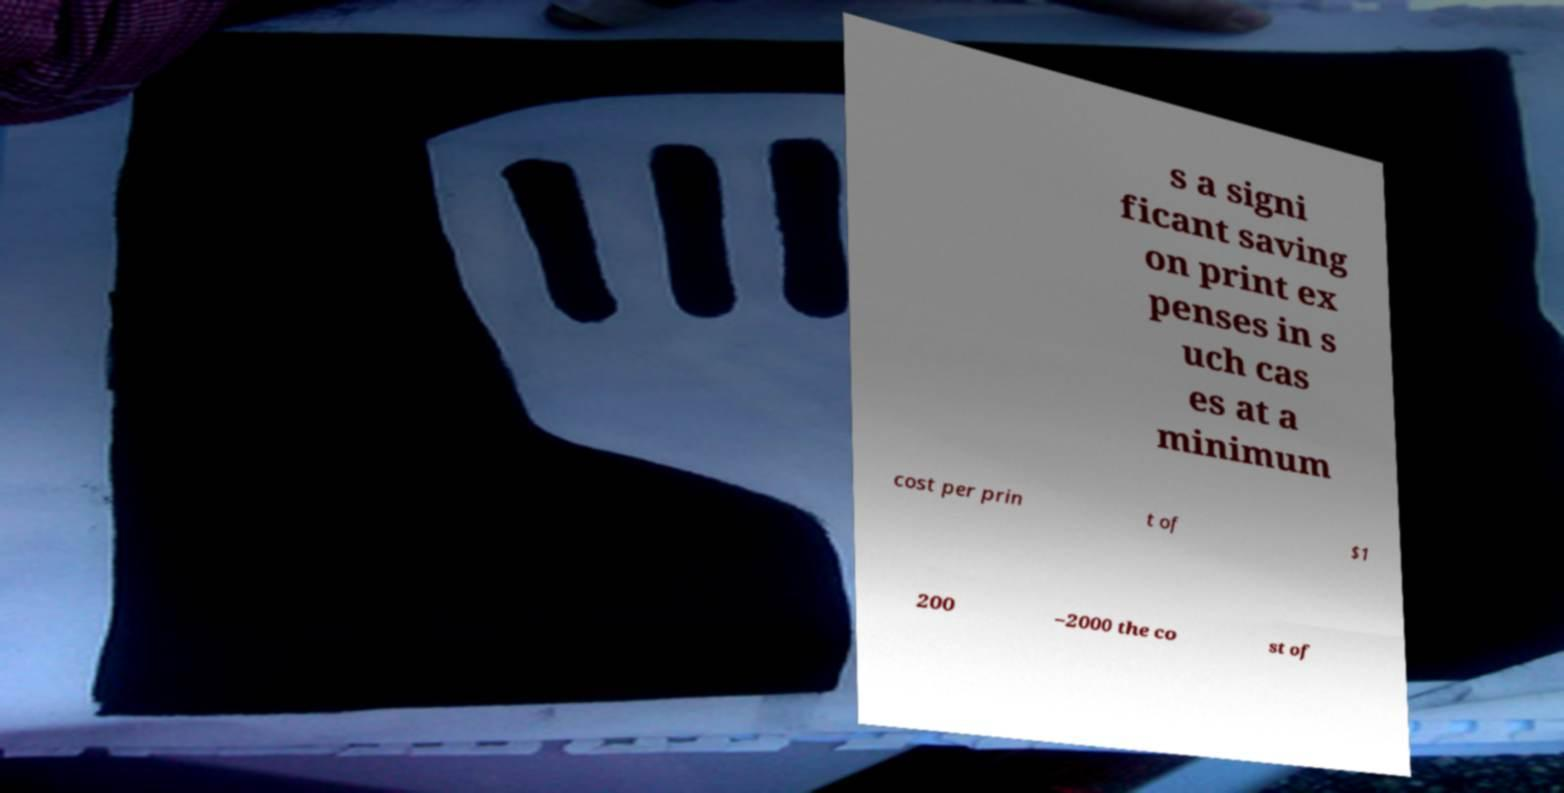What messages or text are displayed in this image? I need them in a readable, typed format. s a signi ficant saving on print ex penses in s uch cas es at a minimum cost per prin t of $1 200 –2000 the co st of 